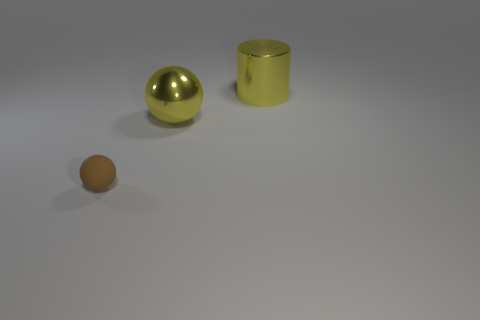Add 3 gray metal things. How many objects exist? 6 Subtract all brown spheres. How many spheres are left? 1 Subtract all red balls. How many brown cylinders are left? 0 Subtract all gray spheres. Subtract all purple cylinders. How many spheres are left? 2 Subtract all large red rubber objects. Subtract all shiny balls. How many objects are left? 2 Add 1 yellow metallic cylinders. How many yellow metallic cylinders are left? 2 Add 1 green blocks. How many green blocks exist? 1 Subtract 0 green balls. How many objects are left? 3 Subtract all balls. How many objects are left? 1 Subtract 1 cylinders. How many cylinders are left? 0 